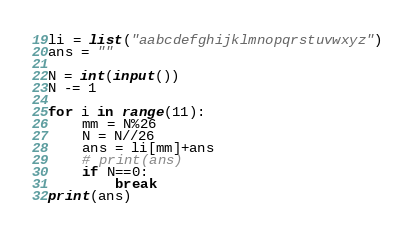<code> <loc_0><loc_0><loc_500><loc_500><_Python_>li = list("aabcdefghijklmnopqrstuvwxyz")
ans = ""

N = int(input())
N -= 1

for i in range(11):
    mm = N%26
    N = N//26
    ans = li[mm]+ans
    # print(ans)
    if N==0:
        break
print(ans)

</code> 